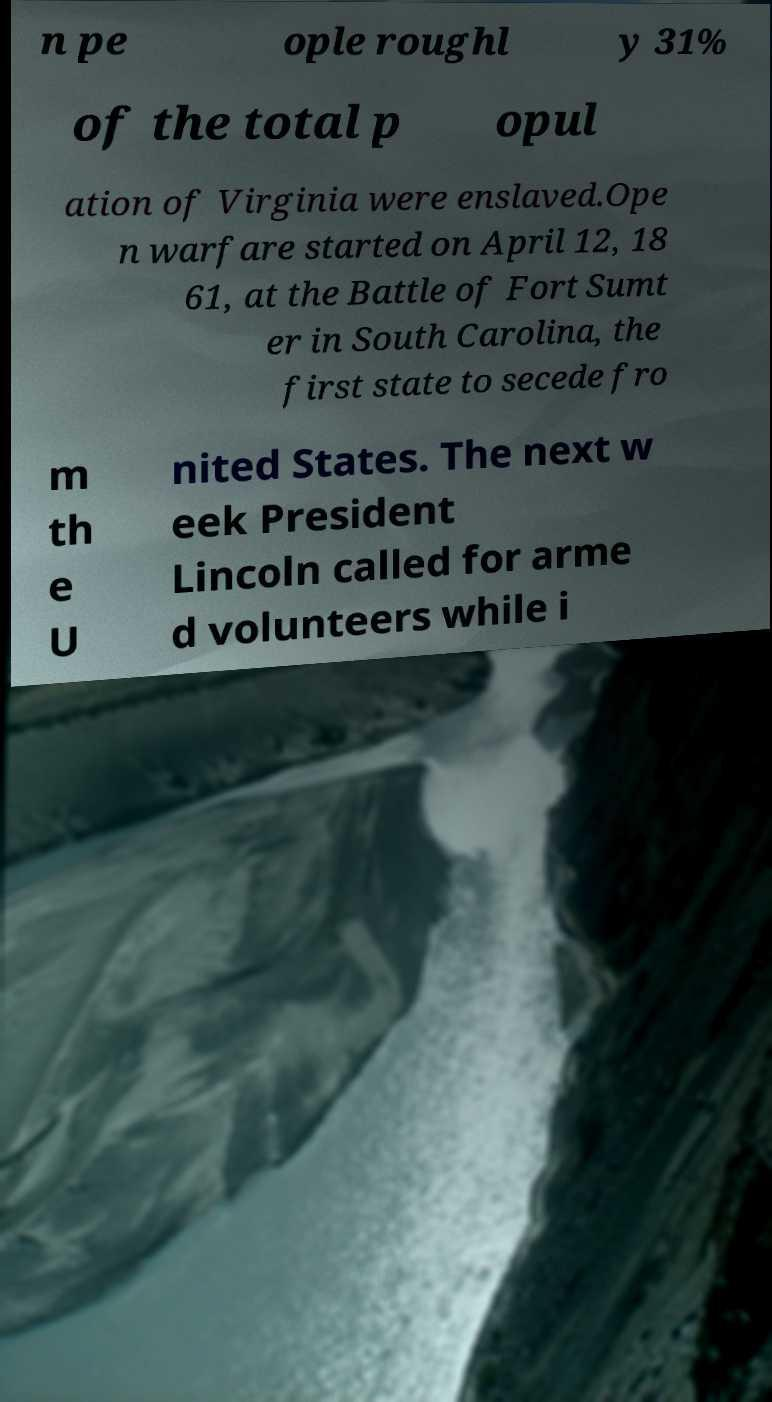There's text embedded in this image that I need extracted. Can you transcribe it verbatim? n pe ople roughl y 31% of the total p opul ation of Virginia were enslaved.Ope n warfare started on April 12, 18 61, at the Battle of Fort Sumt er in South Carolina, the first state to secede fro m th e U nited States. The next w eek President Lincoln called for arme d volunteers while i 